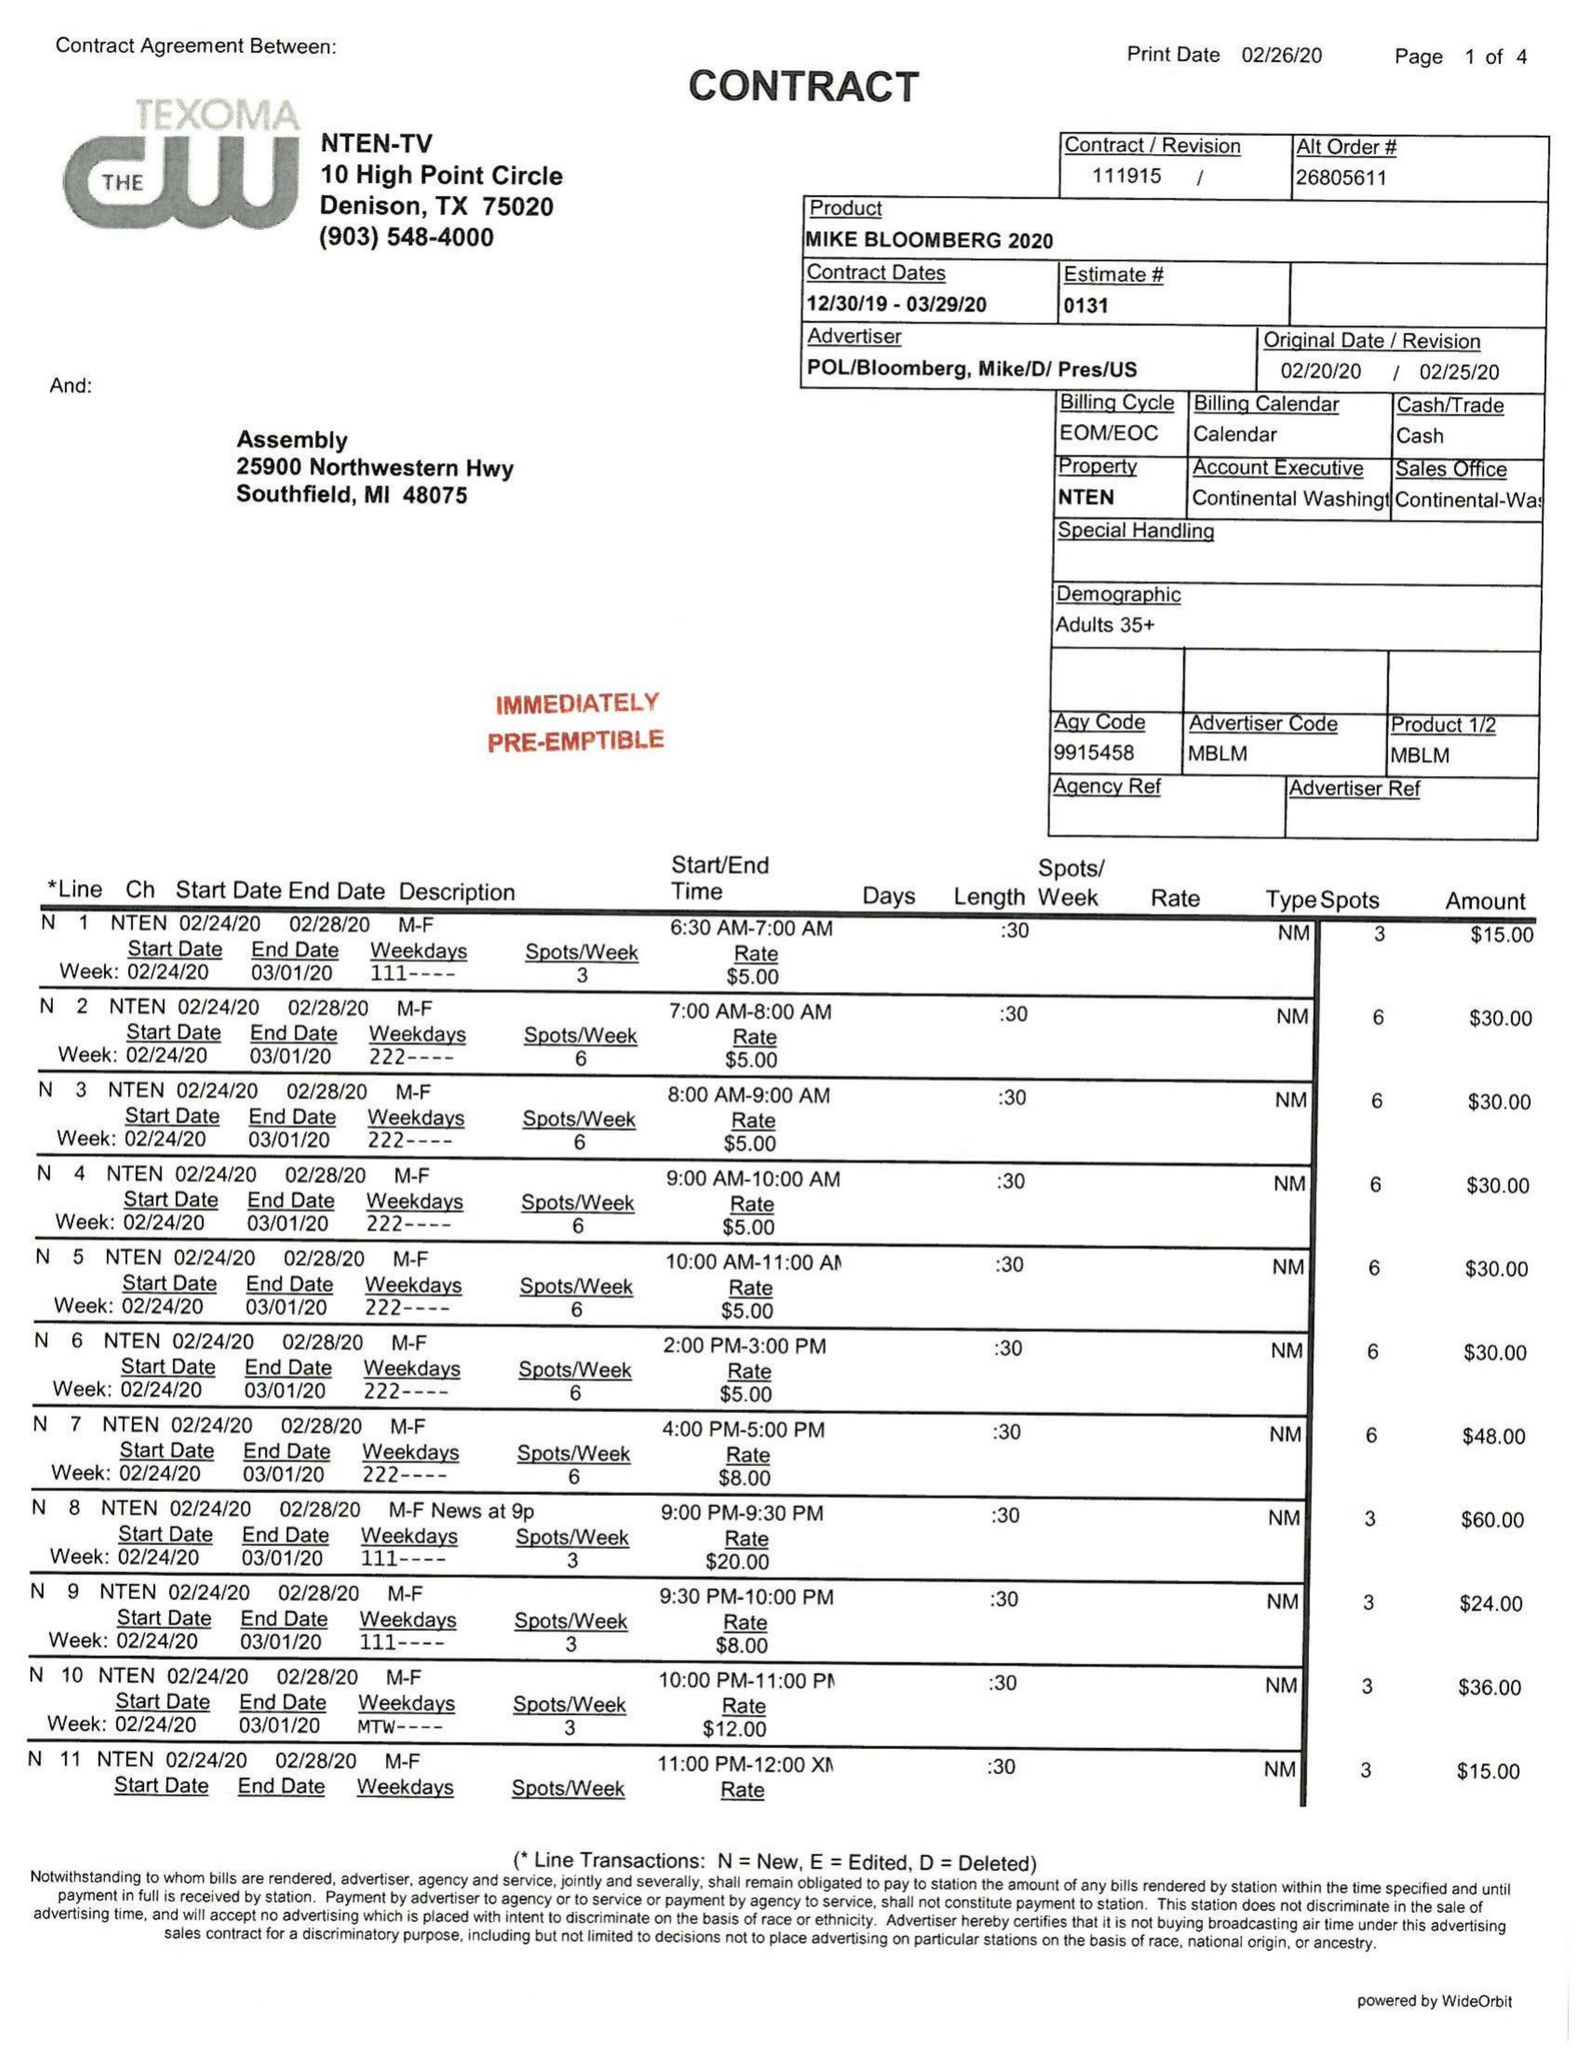What is the value for the flight_from?
Answer the question using a single word or phrase. 12/30/19 